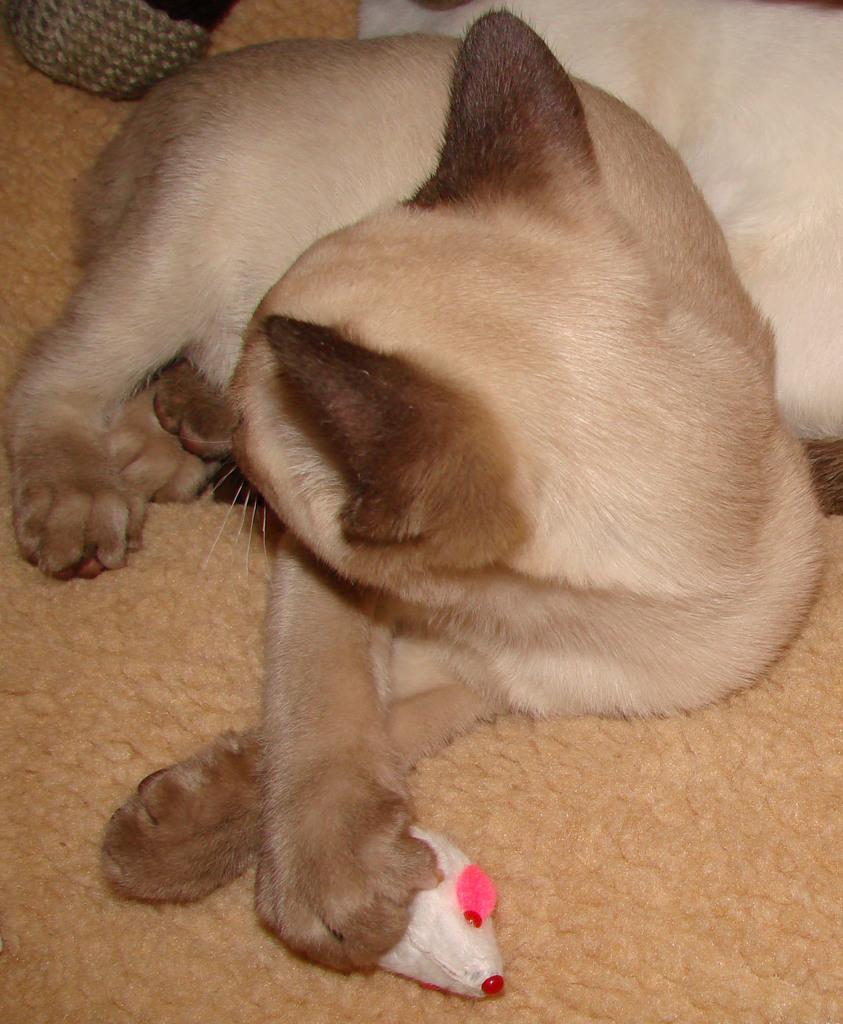How would you summarize this image in a sentence or two? In the image we can see the dog, pale brown in color. Here we can see the toy and the cloth. 